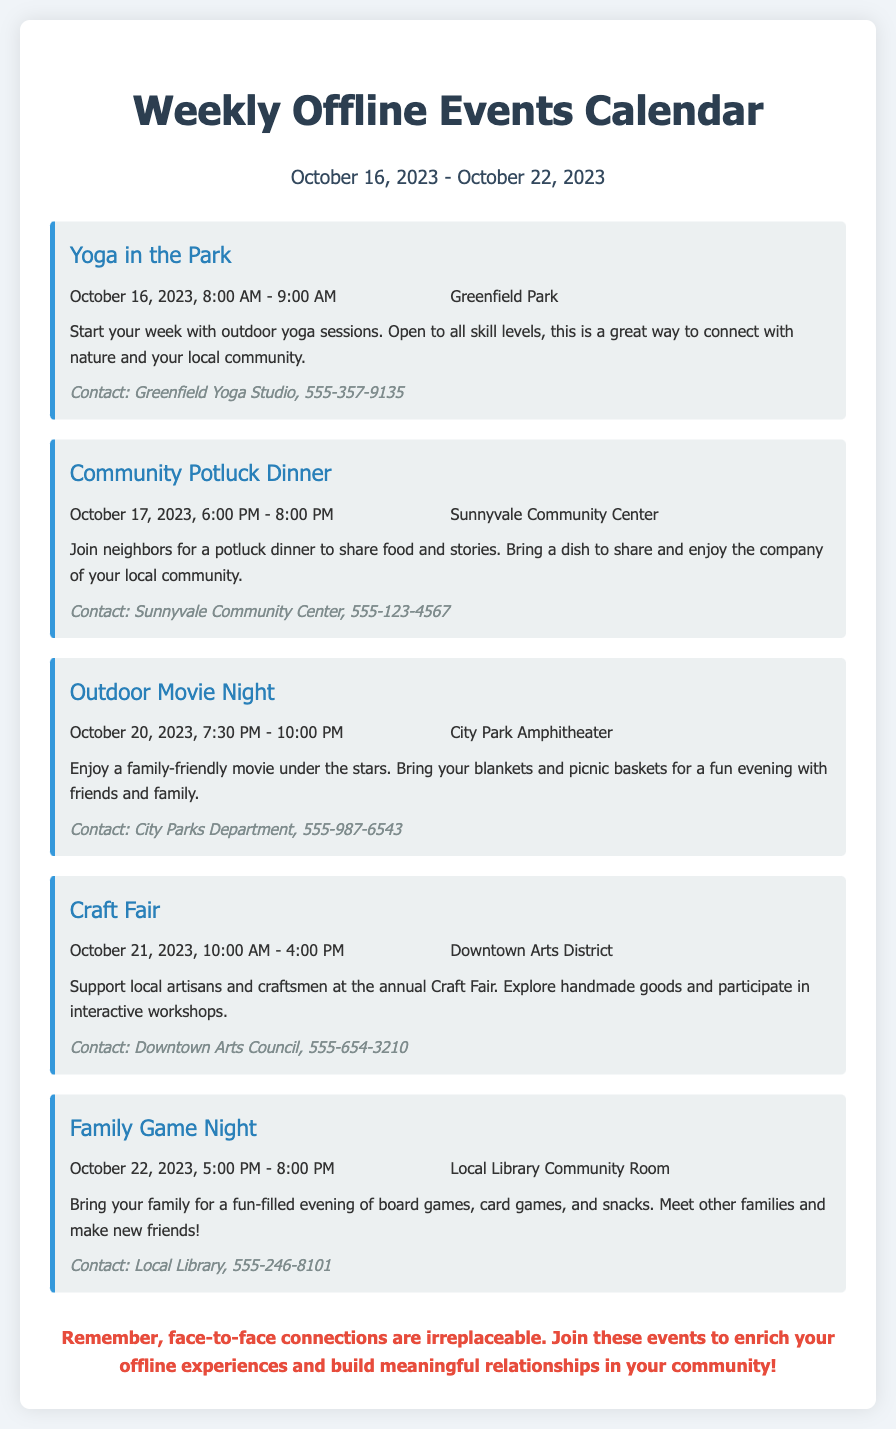What is the first event listed? The first event is identified by its position in the list, and it's titled "Yoga in the Park."
Answer: Yoga in the Park What date and time is the Community Potluck Dinner? This is a specific inquiry regarding the date and time of a particular event, which is "October 17, 2023, 6:00 PM - 8:00 PM."
Answer: October 17, 2023, 6:00 PM - 8:00 PM Where is the Outdoor Movie Night taking place? This asks for the location of a specific event indicated in the document which is "City Park Amphitheater."
Answer: City Park Amphitheater What type of activities can participants expect at the Craft Fair? The question inquires about the nature of participation at the Craft Fair, which includes "explore handmade goods and participate in interactive workshops."
Answer: Handmade goods and interactive workshops How many hours is the Family Game Night scheduled for? The total duration can be calculated based on the start and end times given for the event, which is from "5:00 PM to 8:00 PM," resulting in three hours.
Answer: 3 hours When is the event that emphasizes connecting with nature? This asks for an event specifically linked to nature, which is the "Yoga in the Park."
Answer: Yoga in the Park What is the contact number for the Greenfield Yoga Studio? This requires exact information from the contact details provided in the event listing, which is "555-357-9135."
Answer: 555-357-9135 Which event occurs on October 20, 2023? The question focuses on a specific date to identify which event is happening on that date, which is "Outdoor Movie Night."
Answer: Outdoor Movie Night What is the emphasis in the closing statement of the document? The question involves understanding the key message conveyed at the end of the document, which encourages face-to-face connections.
Answer: Face-to-face connections are irreplaceable 